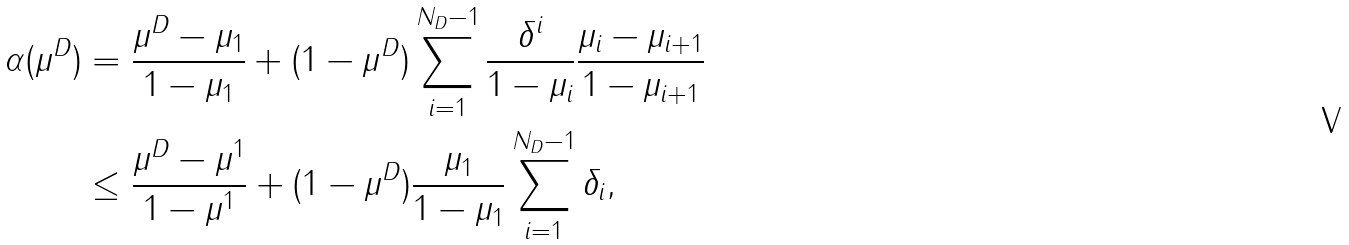<formula> <loc_0><loc_0><loc_500><loc_500>\alpha ( \mu ^ { D } ) & = \frac { \mu ^ { D } - \mu _ { 1 } } { 1 - \mu _ { 1 } } + ( 1 - \mu ^ { D } ) \sum _ { i = 1 } ^ { N _ { D } - 1 } \frac { \delta ^ { i } } { 1 - \mu _ { i } } \frac { \mu _ { i } - \mu _ { i + 1 } } { 1 - \mu _ { i + 1 } } \\ & \leq \frac { \mu ^ { D } - \mu ^ { 1 } } { 1 - \mu ^ { 1 } } + ( 1 - \mu ^ { D } ) \frac { \mu _ { 1 } } { 1 - \mu _ { 1 } } \sum _ { i = 1 } ^ { N _ { D } - 1 } \delta _ { i } ,</formula> 